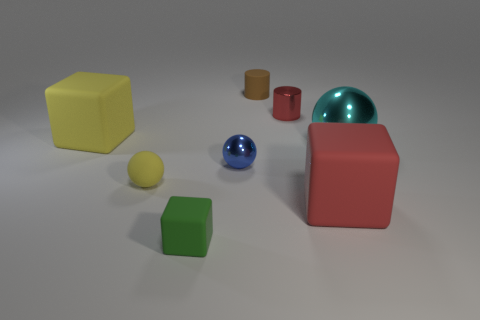Add 2 matte cylinders. How many objects exist? 10 Subtract all blocks. How many objects are left? 5 Add 3 small cyan metallic things. How many small cyan metallic things exist? 3 Subtract 0 purple blocks. How many objects are left? 8 Subtract all small blue shiny spheres. Subtract all small yellow matte objects. How many objects are left? 6 Add 4 small blue things. How many small blue things are left? 5 